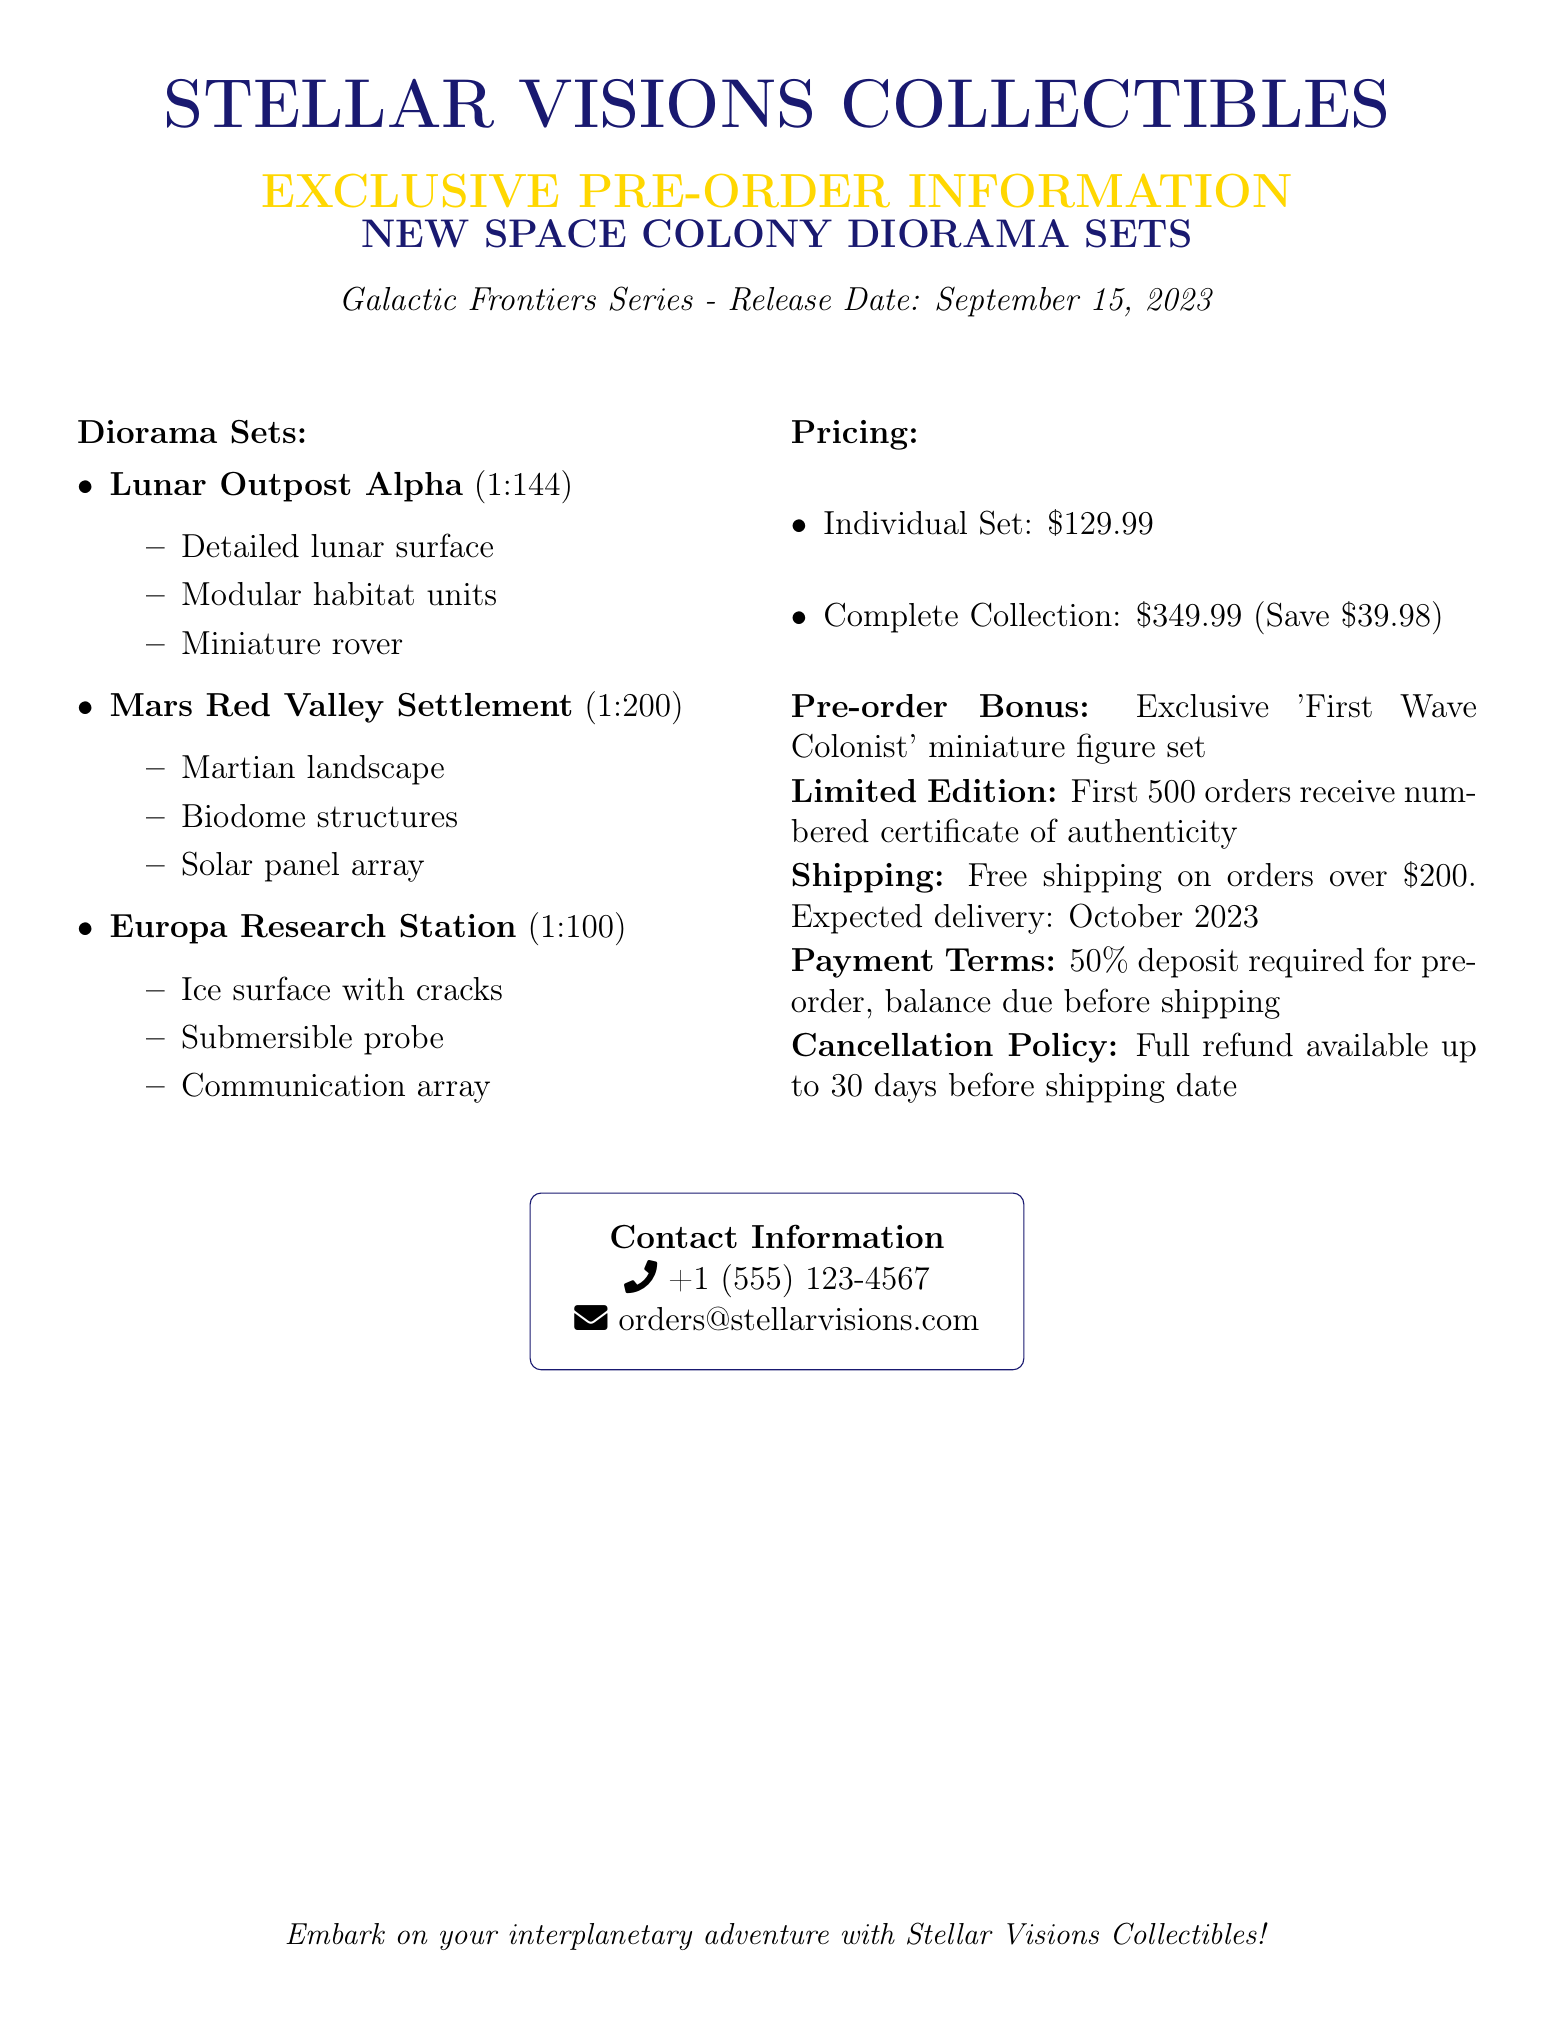What is the title of the new product line? The title of the new product line is explicitly stated as "Galactic Frontiers Series."
Answer: Galactic Frontiers Series When is the release date for the diorama sets? The release date for the diorama sets is provided in the document.
Answer: September 15, 2023 What is the price of the individual diorama set? The price for an individual diorama set is clearly listed.
Answer: $129.99 How many different diorama sets are available? The document lists three separate diorama sets, giving a clear count.
Answer: 3 What is the expected delivery month for the pre-orders? The expected delivery month can be inferred from the shipping information in the document.
Answer: October 2023 What is included as a pre-order bonus? The document specifies what bonus is provided with pre-orders.
Answer: 'First Wave Colonist' miniature figure set How many orders will receive a numbered certificate of authenticity? The document explicitly mentions the limit for the numbered certificates.
Answer: 500 What is the deposit percentage required for pre-orders? The payment terms detail the deposit requirement, giving a specific percentage.
Answer: 50% Is there a cancellation policy mentioned? The Cancellation Policy section indicates the availability of refunds.
Answer: Yes 